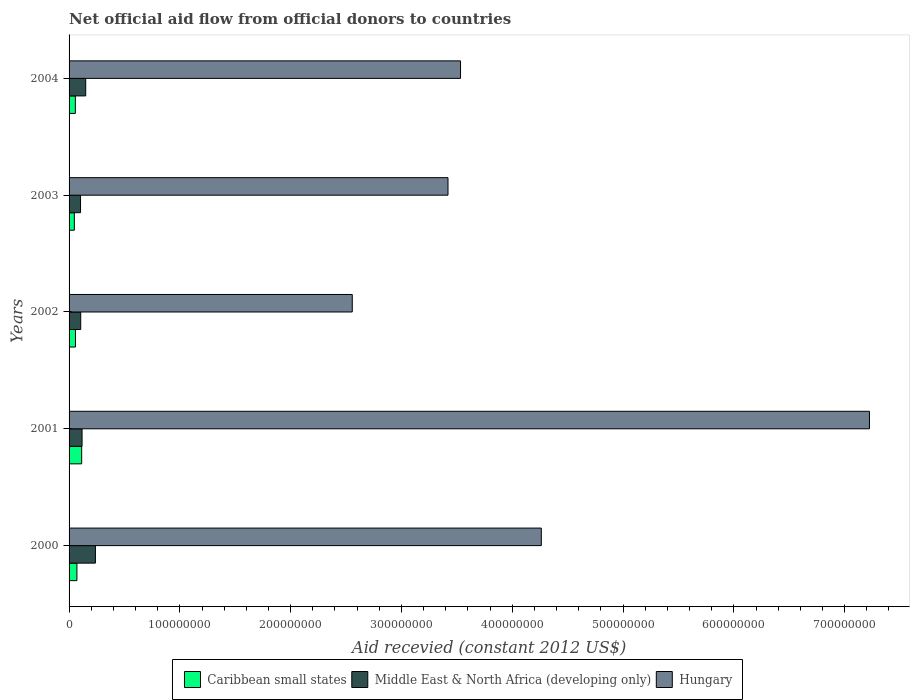Are the number of bars per tick equal to the number of legend labels?
Offer a very short reply. Yes. How many bars are there on the 2nd tick from the bottom?
Offer a terse response. 3. In how many cases, is the number of bars for a given year not equal to the number of legend labels?
Your answer should be very brief. 0. What is the total aid received in Middle East & North Africa (developing only) in 2004?
Offer a very short reply. 1.50e+07. Across all years, what is the maximum total aid received in Hungary?
Your answer should be very brief. 7.22e+08. Across all years, what is the minimum total aid received in Middle East & North Africa (developing only)?
Ensure brevity in your answer.  1.03e+07. What is the total total aid received in Caribbean small states in the graph?
Provide a short and direct response. 3.47e+07. What is the difference between the total aid received in Middle East & North Africa (developing only) in 2001 and that in 2004?
Your answer should be very brief. -3.28e+06. What is the difference between the total aid received in Hungary in 2000 and the total aid received in Caribbean small states in 2001?
Offer a very short reply. 4.15e+08. What is the average total aid received in Middle East & North Africa (developing only) per year?
Offer a very short reply. 1.43e+07. In the year 2002, what is the difference between the total aid received in Middle East & North Africa (developing only) and total aid received in Caribbean small states?
Offer a very short reply. 4.73e+06. In how many years, is the total aid received in Middle East & North Africa (developing only) greater than 720000000 US$?
Offer a terse response. 0. What is the ratio of the total aid received in Caribbean small states in 2000 to that in 2001?
Keep it short and to the point. 0.62. Is the difference between the total aid received in Middle East & North Africa (developing only) in 2001 and 2004 greater than the difference between the total aid received in Caribbean small states in 2001 and 2004?
Make the answer very short. No. What is the difference between the highest and the second highest total aid received in Hungary?
Make the answer very short. 2.96e+08. What is the difference between the highest and the lowest total aid received in Middle East & North Africa (developing only)?
Your response must be concise. 1.34e+07. What does the 3rd bar from the top in 2004 represents?
Keep it short and to the point. Caribbean small states. What does the 1st bar from the bottom in 2001 represents?
Offer a terse response. Caribbean small states. Is it the case that in every year, the sum of the total aid received in Caribbean small states and total aid received in Middle East & North Africa (developing only) is greater than the total aid received in Hungary?
Give a very brief answer. No. How many bars are there?
Provide a short and direct response. 15. Are all the bars in the graph horizontal?
Ensure brevity in your answer.  Yes. Where does the legend appear in the graph?
Give a very brief answer. Bottom center. How many legend labels are there?
Your response must be concise. 3. What is the title of the graph?
Offer a terse response. Net official aid flow from official donors to countries. Does "Antigua and Barbuda" appear as one of the legend labels in the graph?
Provide a short and direct response. No. What is the label or title of the X-axis?
Your answer should be compact. Aid recevied (constant 2012 US$). What is the label or title of the Y-axis?
Provide a succinct answer. Years. What is the Aid recevied (constant 2012 US$) in Caribbean small states in 2000?
Your answer should be compact. 7.08e+06. What is the Aid recevied (constant 2012 US$) of Middle East & North Africa (developing only) in 2000?
Offer a very short reply. 2.38e+07. What is the Aid recevied (constant 2012 US$) in Hungary in 2000?
Keep it short and to the point. 4.26e+08. What is the Aid recevied (constant 2012 US$) of Caribbean small states in 2001?
Provide a succinct answer. 1.14e+07. What is the Aid recevied (constant 2012 US$) in Middle East & North Africa (developing only) in 2001?
Keep it short and to the point. 1.17e+07. What is the Aid recevied (constant 2012 US$) of Hungary in 2001?
Offer a very short reply. 7.22e+08. What is the Aid recevied (constant 2012 US$) in Caribbean small states in 2002?
Your answer should be very brief. 5.78e+06. What is the Aid recevied (constant 2012 US$) in Middle East & North Africa (developing only) in 2002?
Give a very brief answer. 1.05e+07. What is the Aid recevied (constant 2012 US$) in Hungary in 2002?
Give a very brief answer. 2.56e+08. What is the Aid recevied (constant 2012 US$) in Caribbean small states in 2003?
Provide a succinct answer. 4.76e+06. What is the Aid recevied (constant 2012 US$) in Middle East & North Africa (developing only) in 2003?
Offer a very short reply. 1.03e+07. What is the Aid recevied (constant 2012 US$) of Hungary in 2003?
Make the answer very short. 3.42e+08. What is the Aid recevied (constant 2012 US$) of Caribbean small states in 2004?
Your answer should be very brief. 5.66e+06. What is the Aid recevied (constant 2012 US$) in Middle East & North Africa (developing only) in 2004?
Offer a terse response. 1.50e+07. What is the Aid recevied (constant 2012 US$) of Hungary in 2004?
Make the answer very short. 3.53e+08. Across all years, what is the maximum Aid recevied (constant 2012 US$) in Caribbean small states?
Provide a succinct answer. 1.14e+07. Across all years, what is the maximum Aid recevied (constant 2012 US$) of Middle East & North Africa (developing only)?
Give a very brief answer. 2.38e+07. Across all years, what is the maximum Aid recevied (constant 2012 US$) of Hungary?
Make the answer very short. 7.22e+08. Across all years, what is the minimum Aid recevied (constant 2012 US$) of Caribbean small states?
Your answer should be very brief. 4.76e+06. Across all years, what is the minimum Aid recevied (constant 2012 US$) of Middle East & North Africa (developing only)?
Your answer should be very brief. 1.03e+07. Across all years, what is the minimum Aid recevied (constant 2012 US$) of Hungary?
Offer a very short reply. 2.56e+08. What is the total Aid recevied (constant 2012 US$) of Caribbean small states in the graph?
Your response must be concise. 3.47e+07. What is the total Aid recevied (constant 2012 US$) of Middle East & North Africa (developing only) in the graph?
Your response must be concise. 7.14e+07. What is the total Aid recevied (constant 2012 US$) of Hungary in the graph?
Ensure brevity in your answer.  2.10e+09. What is the difference between the Aid recevied (constant 2012 US$) in Caribbean small states in 2000 and that in 2001?
Your answer should be very brief. -4.30e+06. What is the difference between the Aid recevied (constant 2012 US$) of Middle East & North Africa (developing only) in 2000 and that in 2001?
Make the answer very short. 1.21e+07. What is the difference between the Aid recevied (constant 2012 US$) of Hungary in 2000 and that in 2001?
Ensure brevity in your answer.  -2.96e+08. What is the difference between the Aid recevied (constant 2012 US$) in Caribbean small states in 2000 and that in 2002?
Ensure brevity in your answer.  1.30e+06. What is the difference between the Aid recevied (constant 2012 US$) in Middle East & North Africa (developing only) in 2000 and that in 2002?
Offer a terse response. 1.33e+07. What is the difference between the Aid recevied (constant 2012 US$) of Hungary in 2000 and that in 2002?
Your answer should be compact. 1.71e+08. What is the difference between the Aid recevied (constant 2012 US$) in Caribbean small states in 2000 and that in 2003?
Offer a very short reply. 2.32e+06. What is the difference between the Aid recevied (constant 2012 US$) in Middle East & North Africa (developing only) in 2000 and that in 2003?
Offer a terse response. 1.34e+07. What is the difference between the Aid recevied (constant 2012 US$) of Hungary in 2000 and that in 2003?
Offer a very short reply. 8.42e+07. What is the difference between the Aid recevied (constant 2012 US$) of Caribbean small states in 2000 and that in 2004?
Your answer should be very brief. 1.42e+06. What is the difference between the Aid recevied (constant 2012 US$) of Middle East & North Africa (developing only) in 2000 and that in 2004?
Offer a terse response. 8.78e+06. What is the difference between the Aid recevied (constant 2012 US$) of Hungary in 2000 and that in 2004?
Give a very brief answer. 7.29e+07. What is the difference between the Aid recevied (constant 2012 US$) of Caribbean small states in 2001 and that in 2002?
Your response must be concise. 5.60e+06. What is the difference between the Aid recevied (constant 2012 US$) of Middle East & North Africa (developing only) in 2001 and that in 2002?
Provide a succinct answer. 1.22e+06. What is the difference between the Aid recevied (constant 2012 US$) in Hungary in 2001 and that in 2002?
Keep it short and to the point. 4.67e+08. What is the difference between the Aid recevied (constant 2012 US$) of Caribbean small states in 2001 and that in 2003?
Your answer should be very brief. 6.62e+06. What is the difference between the Aid recevied (constant 2012 US$) of Middle East & North Africa (developing only) in 2001 and that in 2003?
Provide a succinct answer. 1.39e+06. What is the difference between the Aid recevied (constant 2012 US$) of Hungary in 2001 and that in 2003?
Your response must be concise. 3.80e+08. What is the difference between the Aid recevied (constant 2012 US$) of Caribbean small states in 2001 and that in 2004?
Your response must be concise. 5.72e+06. What is the difference between the Aid recevied (constant 2012 US$) of Middle East & North Africa (developing only) in 2001 and that in 2004?
Give a very brief answer. -3.28e+06. What is the difference between the Aid recevied (constant 2012 US$) of Hungary in 2001 and that in 2004?
Offer a terse response. 3.69e+08. What is the difference between the Aid recevied (constant 2012 US$) of Caribbean small states in 2002 and that in 2003?
Make the answer very short. 1.02e+06. What is the difference between the Aid recevied (constant 2012 US$) of Hungary in 2002 and that in 2003?
Your answer should be very brief. -8.64e+07. What is the difference between the Aid recevied (constant 2012 US$) in Caribbean small states in 2002 and that in 2004?
Make the answer very short. 1.20e+05. What is the difference between the Aid recevied (constant 2012 US$) in Middle East & North Africa (developing only) in 2002 and that in 2004?
Your answer should be very brief. -4.50e+06. What is the difference between the Aid recevied (constant 2012 US$) of Hungary in 2002 and that in 2004?
Your answer should be compact. -9.77e+07. What is the difference between the Aid recevied (constant 2012 US$) of Caribbean small states in 2003 and that in 2004?
Offer a terse response. -9.00e+05. What is the difference between the Aid recevied (constant 2012 US$) in Middle East & North Africa (developing only) in 2003 and that in 2004?
Offer a very short reply. -4.67e+06. What is the difference between the Aid recevied (constant 2012 US$) in Hungary in 2003 and that in 2004?
Keep it short and to the point. -1.13e+07. What is the difference between the Aid recevied (constant 2012 US$) in Caribbean small states in 2000 and the Aid recevied (constant 2012 US$) in Middle East & North Africa (developing only) in 2001?
Keep it short and to the point. -4.65e+06. What is the difference between the Aid recevied (constant 2012 US$) of Caribbean small states in 2000 and the Aid recevied (constant 2012 US$) of Hungary in 2001?
Offer a terse response. -7.15e+08. What is the difference between the Aid recevied (constant 2012 US$) of Middle East & North Africa (developing only) in 2000 and the Aid recevied (constant 2012 US$) of Hungary in 2001?
Give a very brief answer. -6.99e+08. What is the difference between the Aid recevied (constant 2012 US$) in Caribbean small states in 2000 and the Aid recevied (constant 2012 US$) in Middle East & North Africa (developing only) in 2002?
Your answer should be compact. -3.43e+06. What is the difference between the Aid recevied (constant 2012 US$) in Caribbean small states in 2000 and the Aid recevied (constant 2012 US$) in Hungary in 2002?
Give a very brief answer. -2.49e+08. What is the difference between the Aid recevied (constant 2012 US$) in Middle East & North Africa (developing only) in 2000 and the Aid recevied (constant 2012 US$) in Hungary in 2002?
Give a very brief answer. -2.32e+08. What is the difference between the Aid recevied (constant 2012 US$) in Caribbean small states in 2000 and the Aid recevied (constant 2012 US$) in Middle East & North Africa (developing only) in 2003?
Keep it short and to the point. -3.26e+06. What is the difference between the Aid recevied (constant 2012 US$) in Caribbean small states in 2000 and the Aid recevied (constant 2012 US$) in Hungary in 2003?
Offer a terse response. -3.35e+08. What is the difference between the Aid recevied (constant 2012 US$) in Middle East & North Africa (developing only) in 2000 and the Aid recevied (constant 2012 US$) in Hungary in 2003?
Ensure brevity in your answer.  -3.18e+08. What is the difference between the Aid recevied (constant 2012 US$) of Caribbean small states in 2000 and the Aid recevied (constant 2012 US$) of Middle East & North Africa (developing only) in 2004?
Your answer should be very brief. -7.93e+06. What is the difference between the Aid recevied (constant 2012 US$) of Caribbean small states in 2000 and the Aid recevied (constant 2012 US$) of Hungary in 2004?
Offer a very short reply. -3.46e+08. What is the difference between the Aid recevied (constant 2012 US$) in Middle East & North Africa (developing only) in 2000 and the Aid recevied (constant 2012 US$) in Hungary in 2004?
Offer a terse response. -3.30e+08. What is the difference between the Aid recevied (constant 2012 US$) of Caribbean small states in 2001 and the Aid recevied (constant 2012 US$) of Middle East & North Africa (developing only) in 2002?
Offer a terse response. 8.70e+05. What is the difference between the Aid recevied (constant 2012 US$) of Caribbean small states in 2001 and the Aid recevied (constant 2012 US$) of Hungary in 2002?
Your answer should be very brief. -2.44e+08. What is the difference between the Aid recevied (constant 2012 US$) of Middle East & North Africa (developing only) in 2001 and the Aid recevied (constant 2012 US$) of Hungary in 2002?
Keep it short and to the point. -2.44e+08. What is the difference between the Aid recevied (constant 2012 US$) of Caribbean small states in 2001 and the Aid recevied (constant 2012 US$) of Middle East & North Africa (developing only) in 2003?
Your response must be concise. 1.04e+06. What is the difference between the Aid recevied (constant 2012 US$) of Caribbean small states in 2001 and the Aid recevied (constant 2012 US$) of Hungary in 2003?
Offer a very short reply. -3.31e+08. What is the difference between the Aid recevied (constant 2012 US$) in Middle East & North Africa (developing only) in 2001 and the Aid recevied (constant 2012 US$) in Hungary in 2003?
Ensure brevity in your answer.  -3.30e+08. What is the difference between the Aid recevied (constant 2012 US$) of Caribbean small states in 2001 and the Aid recevied (constant 2012 US$) of Middle East & North Africa (developing only) in 2004?
Keep it short and to the point. -3.63e+06. What is the difference between the Aid recevied (constant 2012 US$) in Caribbean small states in 2001 and the Aid recevied (constant 2012 US$) in Hungary in 2004?
Make the answer very short. -3.42e+08. What is the difference between the Aid recevied (constant 2012 US$) of Middle East & North Africa (developing only) in 2001 and the Aid recevied (constant 2012 US$) of Hungary in 2004?
Provide a short and direct response. -3.42e+08. What is the difference between the Aid recevied (constant 2012 US$) of Caribbean small states in 2002 and the Aid recevied (constant 2012 US$) of Middle East & North Africa (developing only) in 2003?
Ensure brevity in your answer.  -4.56e+06. What is the difference between the Aid recevied (constant 2012 US$) of Caribbean small states in 2002 and the Aid recevied (constant 2012 US$) of Hungary in 2003?
Provide a succinct answer. -3.36e+08. What is the difference between the Aid recevied (constant 2012 US$) in Middle East & North Africa (developing only) in 2002 and the Aid recevied (constant 2012 US$) in Hungary in 2003?
Your answer should be very brief. -3.32e+08. What is the difference between the Aid recevied (constant 2012 US$) in Caribbean small states in 2002 and the Aid recevied (constant 2012 US$) in Middle East & North Africa (developing only) in 2004?
Offer a terse response. -9.23e+06. What is the difference between the Aid recevied (constant 2012 US$) in Caribbean small states in 2002 and the Aid recevied (constant 2012 US$) in Hungary in 2004?
Offer a very short reply. -3.48e+08. What is the difference between the Aid recevied (constant 2012 US$) of Middle East & North Africa (developing only) in 2002 and the Aid recevied (constant 2012 US$) of Hungary in 2004?
Your answer should be compact. -3.43e+08. What is the difference between the Aid recevied (constant 2012 US$) of Caribbean small states in 2003 and the Aid recevied (constant 2012 US$) of Middle East & North Africa (developing only) in 2004?
Offer a very short reply. -1.02e+07. What is the difference between the Aid recevied (constant 2012 US$) in Caribbean small states in 2003 and the Aid recevied (constant 2012 US$) in Hungary in 2004?
Your response must be concise. -3.49e+08. What is the difference between the Aid recevied (constant 2012 US$) of Middle East & North Africa (developing only) in 2003 and the Aid recevied (constant 2012 US$) of Hungary in 2004?
Give a very brief answer. -3.43e+08. What is the average Aid recevied (constant 2012 US$) of Caribbean small states per year?
Provide a short and direct response. 6.93e+06. What is the average Aid recevied (constant 2012 US$) in Middle East & North Africa (developing only) per year?
Provide a short and direct response. 1.43e+07. What is the average Aid recevied (constant 2012 US$) of Hungary per year?
Make the answer very short. 4.20e+08. In the year 2000, what is the difference between the Aid recevied (constant 2012 US$) of Caribbean small states and Aid recevied (constant 2012 US$) of Middle East & North Africa (developing only)?
Make the answer very short. -1.67e+07. In the year 2000, what is the difference between the Aid recevied (constant 2012 US$) of Caribbean small states and Aid recevied (constant 2012 US$) of Hungary?
Offer a very short reply. -4.19e+08. In the year 2000, what is the difference between the Aid recevied (constant 2012 US$) of Middle East & North Africa (developing only) and Aid recevied (constant 2012 US$) of Hungary?
Keep it short and to the point. -4.02e+08. In the year 2001, what is the difference between the Aid recevied (constant 2012 US$) in Caribbean small states and Aid recevied (constant 2012 US$) in Middle East & North Africa (developing only)?
Offer a terse response. -3.50e+05. In the year 2001, what is the difference between the Aid recevied (constant 2012 US$) in Caribbean small states and Aid recevied (constant 2012 US$) in Hungary?
Keep it short and to the point. -7.11e+08. In the year 2001, what is the difference between the Aid recevied (constant 2012 US$) of Middle East & North Africa (developing only) and Aid recevied (constant 2012 US$) of Hungary?
Ensure brevity in your answer.  -7.11e+08. In the year 2002, what is the difference between the Aid recevied (constant 2012 US$) of Caribbean small states and Aid recevied (constant 2012 US$) of Middle East & North Africa (developing only)?
Ensure brevity in your answer.  -4.73e+06. In the year 2002, what is the difference between the Aid recevied (constant 2012 US$) in Caribbean small states and Aid recevied (constant 2012 US$) in Hungary?
Keep it short and to the point. -2.50e+08. In the year 2002, what is the difference between the Aid recevied (constant 2012 US$) in Middle East & North Africa (developing only) and Aid recevied (constant 2012 US$) in Hungary?
Your response must be concise. -2.45e+08. In the year 2003, what is the difference between the Aid recevied (constant 2012 US$) of Caribbean small states and Aid recevied (constant 2012 US$) of Middle East & North Africa (developing only)?
Your response must be concise. -5.58e+06. In the year 2003, what is the difference between the Aid recevied (constant 2012 US$) in Caribbean small states and Aid recevied (constant 2012 US$) in Hungary?
Your answer should be very brief. -3.37e+08. In the year 2003, what is the difference between the Aid recevied (constant 2012 US$) of Middle East & North Africa (developing only) and Aid recevied (constant 2012 US$) of Hungary?
Your response must be concise. -3.32e+08. In the year 2004, what is the difference between the Aid recevied (constant 2012 US$) in Caribbean small states and Aid recevied (constant 2012 US$) in Middle East & North Africa (developing only)?
Give a very brief answer. -9.35e+06. In the year 2004, what is the difference between the Aid recevied (constant 2012 US$) of Caribbean small states and Aid recevied (constant 2012 US$) of Hungary?
Keep it short and to the point. -3.48e+08. In the year 2004, what is the difference between the Aid recevied (constant 2012 US$) in Middle East & North Africa (developing only) and Aid recevied (constant 2012 US$) in Hungary?
Offer a very short reply. -3.38e+08. What is the ratio of the Aid recevied (constant 2012 US$) of Caribbean small states in 2000 to that in 2001?
Your answer should be very brief. 0.62. What is the ratio of the Aid recevied (constant 2012 US$) in Middle East & North Africa (developing only) in 2000 to that in 2001?
Provide a short and direct response. 2.03. What is the ratio of the Aid recevied (constant 2012 US$) of Hungary in 2000 to that in 2001?
Keep it short and to the point. 0.59. What is the ratio of the Aid recevied (constant 2012 US$) in Caribbean small states in 2000 to that in 2002?
Your answer should be very brief. 1.22. What is the ratio of the Aid recevied (constant 2012 US$) in Middle East & North Africa (developing only) in 2000 to that in 2002?
Give a very brief answer. 2.26. What is the ratio of the Aid recevied (constant 2012 US$) in Hungary in 2000 to that in 2002?
Provide a succinct answer. 1.67. What is the ratio of the Aid recevied (constant 2012 US$) in Caribbean small states in 2000 to that in 2003?
Offer a very short reply. 1.49. What is the ratio of the Aid recevied (constant 2012 US$) of Middle East & North Africa (developing only) in 2000 to that in 2003?
Keep it short and to the point. 2.3. What is the ratio of the Aid recevied (constant 2012 US$) in Hungary in 2000 to that in 2003?
Your answer should be compact. 1.25. What is the ratio of the Aid recevied (constant 2012 US$) in Caribbean small states in 2000 to that in 2004?
Your answer should be compact. 1.25. What is the ratio of the Aid recevied (constant 2012 US$) in Middle East & North Africa (developing only) in 2000 to that in 2004?
Keep it short and to the point. 1.58. What is the ratio of the Aid recevied (constant 2012 US$) of Hungary in 2000 to that in 2004?
Give a very brief answer. 1.21. What is the ratio of the Aid recevied (constant 2012 US$) in Caribbean small states in 2001 to that in 2002?
Offer a very short reply. 1.97. What is the ratio of the Aid recevied (constant 2012 US$) of Middle East & North Africa (developing only) in 2001 to that in 2002?
Make the answer very short. 1.12. What is the ratio of the Aid recevied (constant 2012 US$) in Hungary in 2001 to that in 2002?
Provide a succinct answer. 2.83. What is the ratio of the Aid recevied (constant 2012 US$) of Caribbean small states in 2001 to that in 2003?
Your answer should be very brief. 2.39. What is the ratio of the Aid recevied (constant 2012 US$) of Middle East & North Africa (developing only) in 2001 to that in 2003?
Make the answer very short. 1.13. What is the ratio of the Aid recevied (constant 2012 US$) of Hungary in 2001 to that in 2003?
Your answer should be compact. 2.11. What is the ratio of the Aid recevied (constant 2012 US$) of Caribbean small states in 2001 to that in 2004?
Ensure brevity in your answer.  2.01. What is the ratio of the Aid recevied (constant 2012 US$) of Middle East & North Africa (developing only) in 2001 to that in 2004?
Ensure brevity in your answer.  0.78. What is the ratio of the Aid recevied (constant 2012 US$) in Hungary in 2001 to that in 2004?
Your answer should be compact. 2.04. What is the ratio of the Aid recevied (constant 2012 US$) of Caribbean small states in 2002 to that in 2003?
Ensure brevity in your answer.  1.21. What is the ratio of the Aid recevied (constant 2012 US$) of Middle East & North Africa (developing only) in 2002 to that in 2003?
Give a very brief answer. 1.02. What is the ratio of the Aid recevied (constant 2012 US$) of Hungary in 2002 to that in 2003?
Offer a very short reply. 0.75. What is the ratio of the Aid recevied (constant 2012 US$) of Caribbean small states in 2002 to that in 2004?
Your answer should be compact. 1.02. What is the ratio of the Aid recevied (constant 2012 US$) of Middle East & North Africa (developing only) in 2002 to that in 2004?
Your response must be concise. 0.7. What is the ratio of the Aid recevied (constant 2012 US$) in Hungary in 2002 to that in 2004?
Your answer should be very brief. 0.72. What is the ratio of the Aid recevied (constant 2012 US$) of Caribbean small states in 2003 to that in 2004?
Provide a succinct answer. 0.84. What is the ratio of the Aid recevied (constant 2012 US$) of Middle East & North Africa (developing only) in 2003 to that in 2004?
Provide a short and direct response. 0.69. What is the difference between the highest and the second highest Aid recevied (constant 2012 US$) in Caribbean small states?
Your response must be concise. 4.30e+06. What is the difference between the highest and the second highest Aid recevied (constant 2012 US$) of Middle East & North Africa (developing only)?
Keep it short and to the point. 8.78e+06. What is the difference between the highest and the second highest Aid recevied (constant 2012 US$) of Hungary?
Offer a terse response. 2.96e+08. What is the difference between the highest and the lowest Aid recevied (constant 2012 US$) of Caribbean small states?
Give a very brief answer. 6.62e+06. What is the difference between the highest and the lowest Aid recevied (constant 2012 US$) of Middle East & North Africa (developing only)?
Give a very brief answer. 1.34e+07. What is the difference between the highest and the lowest Aid recevied (constant 2012 US$) in Hungary?
Offer a terse response. 4.67e+08. 